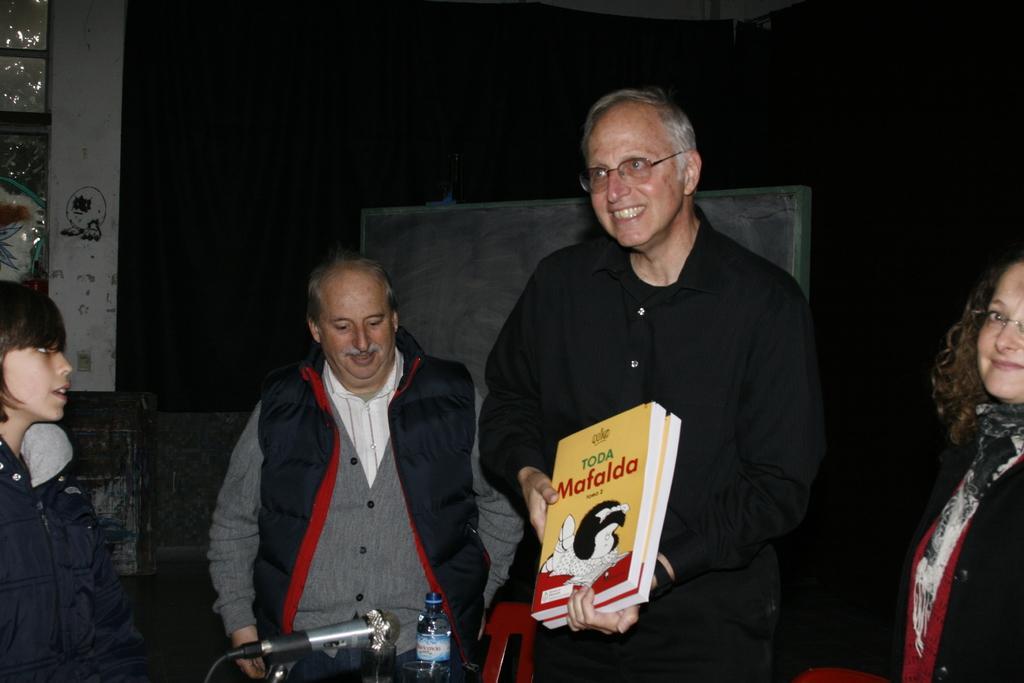How would you summarize this image in a sentence or two? There are people standing and this man holding books,in front of these people we can see microphone and bottle. Background we can see board and it is dark. 